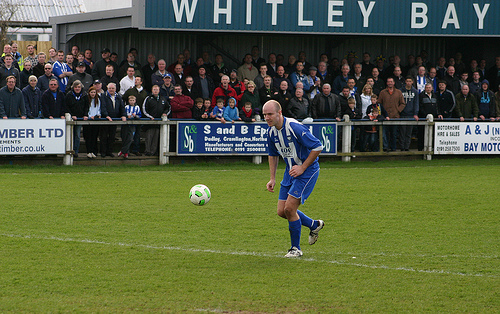<image>
Is there a football behind the player? No. The football is not behind the player. From this viewpoint, the football appears to be positioned elsewhere in the scene. Is there a player on the soccer ball? No. The player is not positioned on the soccer ball. They may be near each other, but the player is not supported by or resting on top of the soccer ball. 